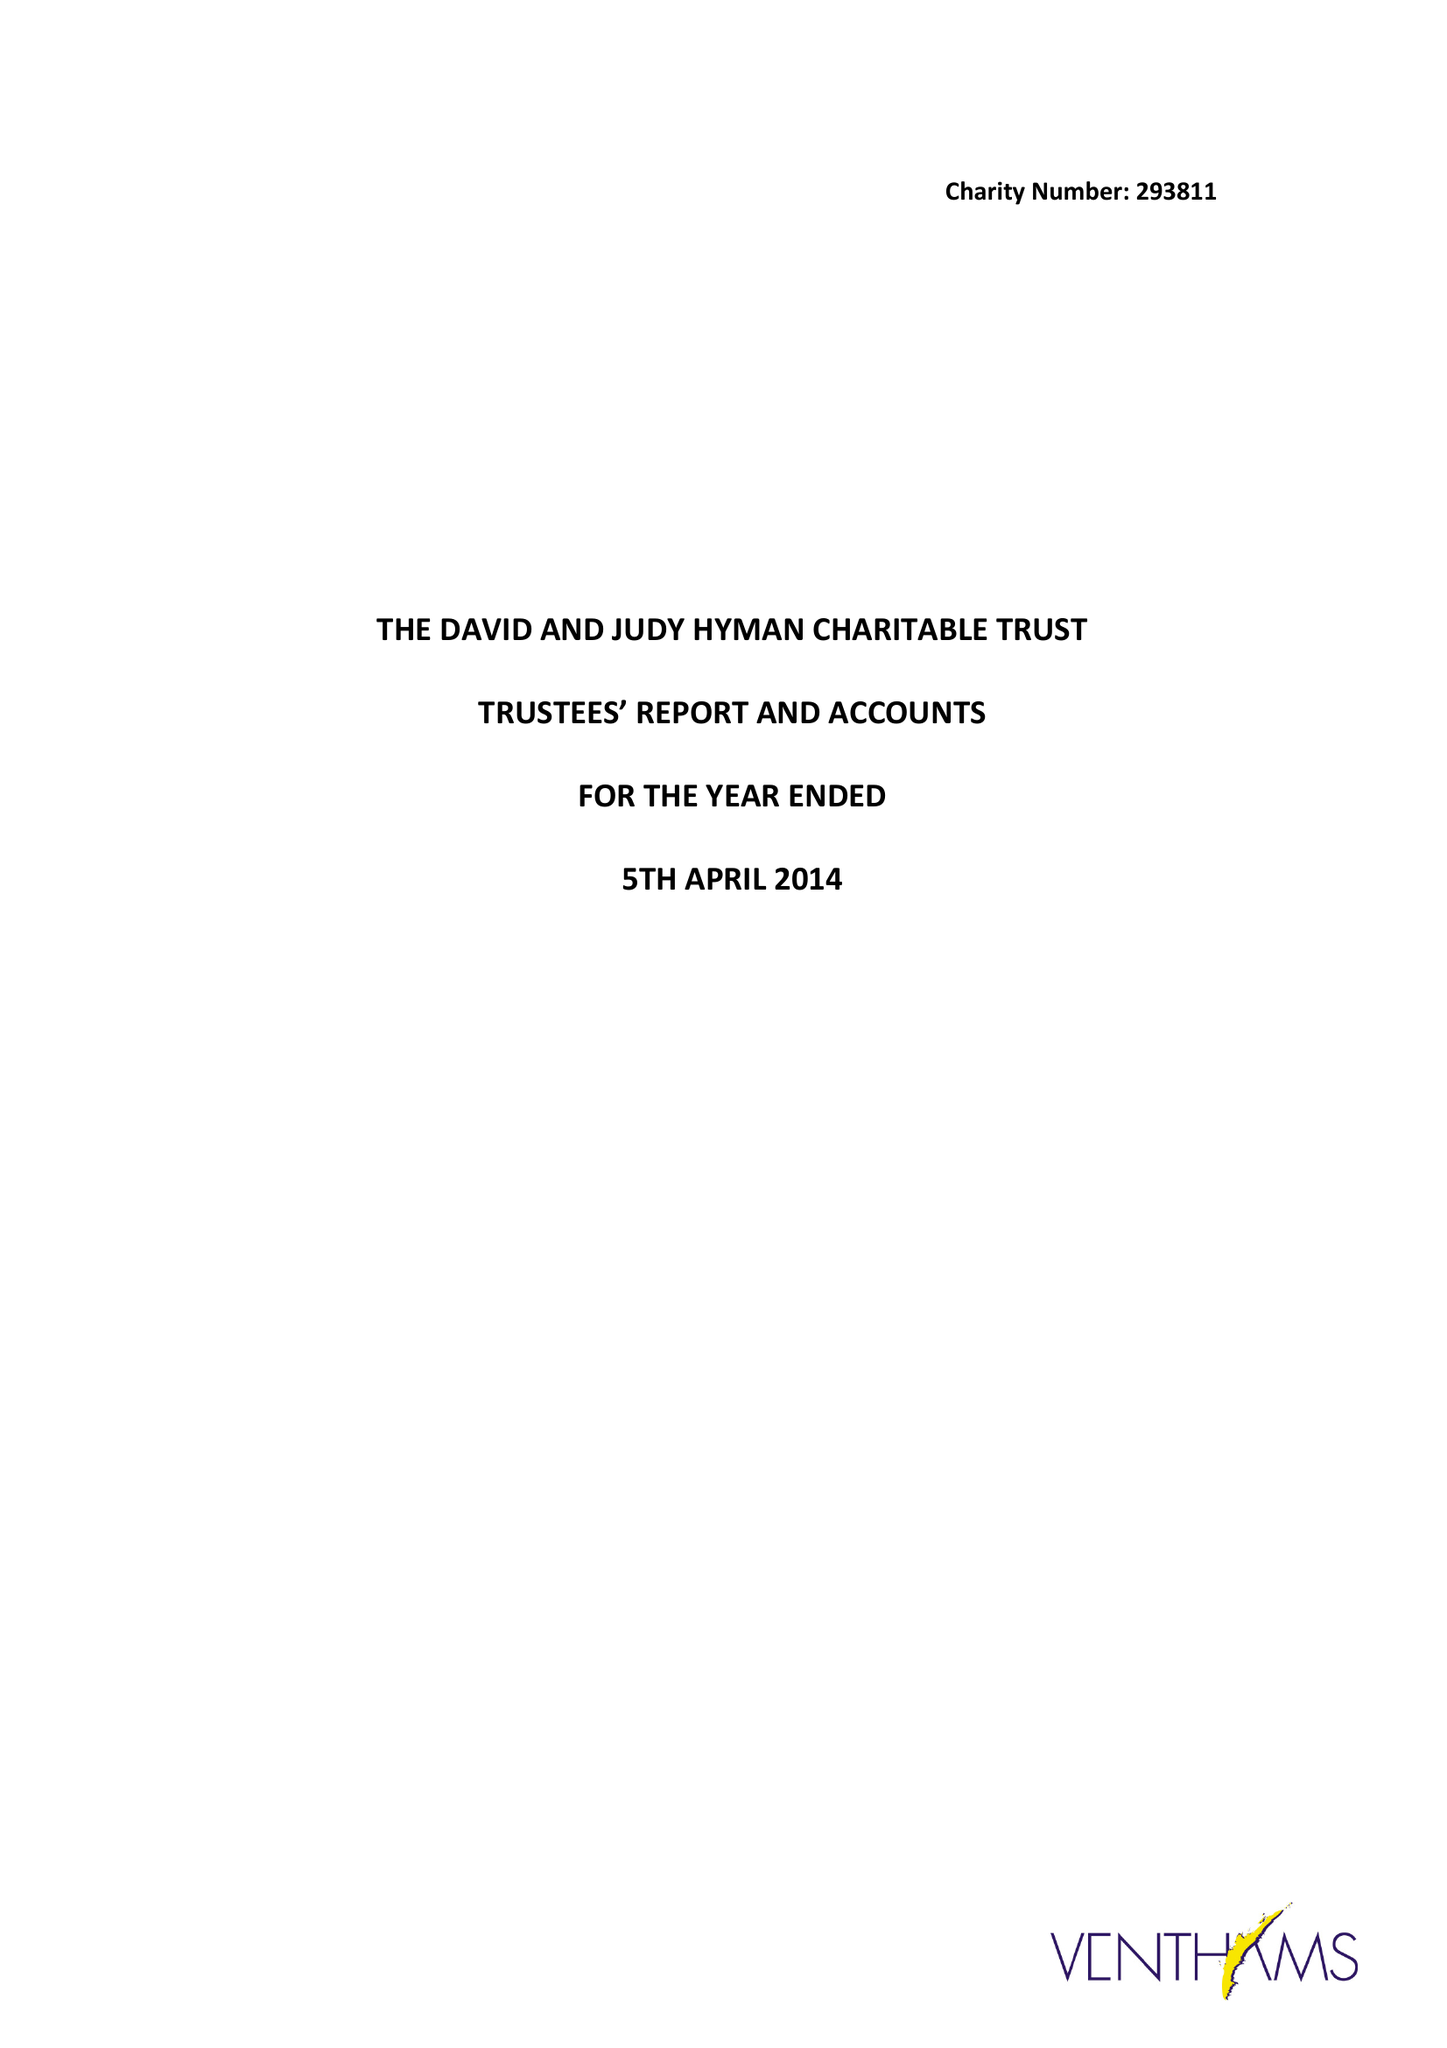What is the value for the address__post_town?
Answer the question using a single word or phrase. LONDON 